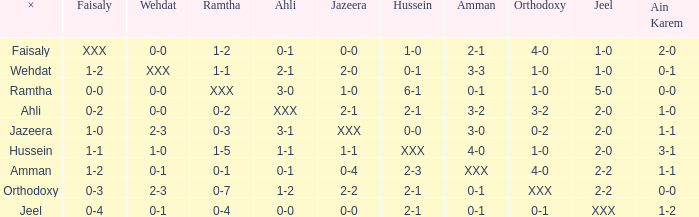What is the meaning of ahli when ramtha's scoreline reads 0-4? 0-0. Can you parse all the data within this table? {'header': ['×', 'Faisaly', 'Wehdat', 'Ramtha', 'Ahli', 'Jazeera', 'Hussein', 'Amman', 'Orthodoxy', 'Jeel', 'Ain Karem'], 'rows': [['Faisaly', 'XXX', '0-0', '1-2', '0-1', '0-0', '1-0', '2-1', '4-0', '1-0', '2-0'], ['Wehdat', '1-2', 'XXX', '1-1', '2-1', '2-0', '0-1', '3-3', '1-0', '1-0', '0-1'], ['Ramtha', '0-0', '0-0', 'XXX', '3-0', '1-0', '6-1', '0-1', '1-0', '5-0', '0-0'], ['Ahli', '0-2', '0-0', '0-2', 'XXX', '2-1', '2-1', '3-2', '3-2', '2-0', '1-0'], ['Jazeera', '1-0', '2-3', '0-3', '3-1', 'XXX', '0-0', '3-0', '0-2', '2-0', '1-1'], ['Hussein', '1-1', '1-0', '1-5', '1-1', '1-1', 'XXX', '4-0', '1-0', '2-0', '3-1'], ['Amman', '1-2', '0-1', '0-1', '0-1', '0-4', '2-3', 'XXX', '4-0', '2-2', '1-1'], ['Orthodoxy', '0-3', '2-3', '0-7', '1-2', '2-2', '2-1', '0-1', 'XXX', '2-2', '0-0'], ['Jeel', '0-4', '0-1', '0-4', '0-0', '0-0', '2-1', '0-1', '0-1', 'XXX', '1-2']]} 